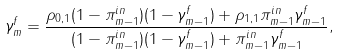<formula> <loc_0><loc_0><loc_500><loc_500>\gamma _ { m } ^ { f } = \frac { \rho _ { 0 , 1 } ( 1 - \pi _ { m - 1 } ^ { i n } ) ( 1 - \gamma _ { m - 1 } ^ { f } ) + \rho _ { 1 , 1 } \pi _ { m - 1 } ^ { i n } \gamma _ { m - 1 } ^ { f } } { ( 1 - \pi _ { m - 1 } ^ { i n } ) ( 1 - \gamma _ { m - 1 } ^ { f } ) + \pi _ { m - 1 } ^ { i n } \gamma _ { m - 1 } ^ { f } } ,</formula> 